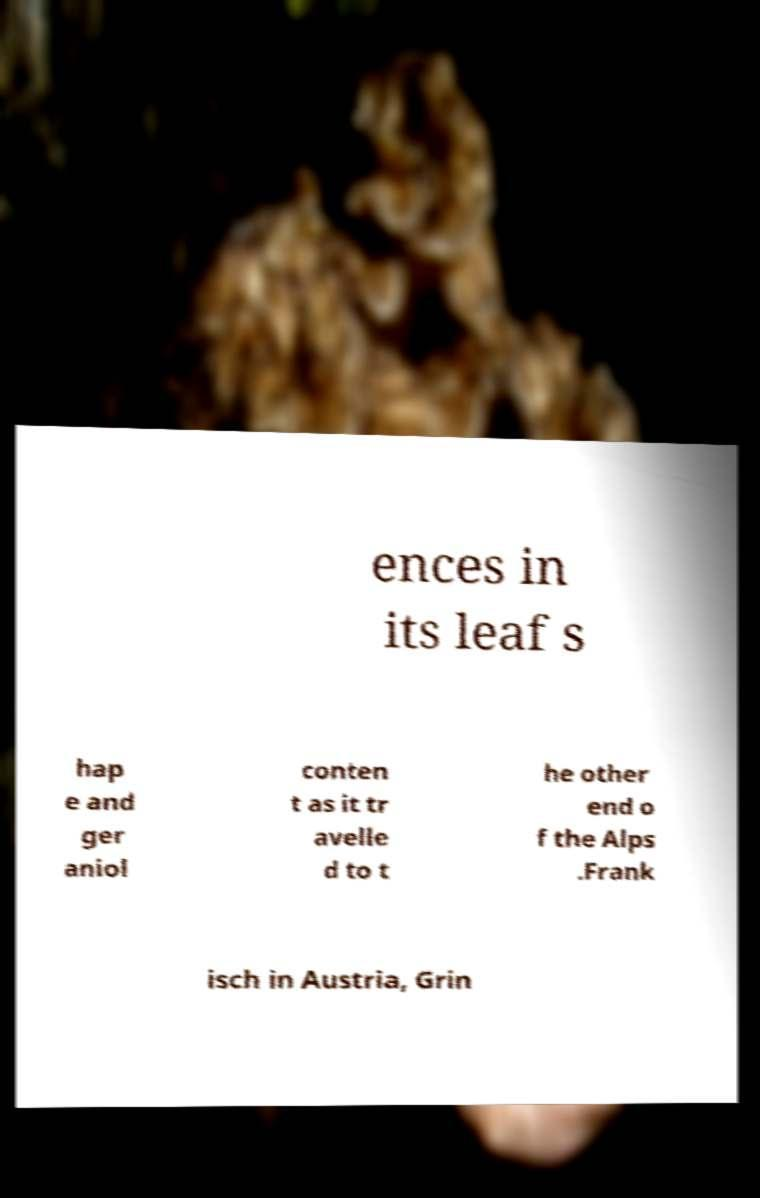Can you read and provide the text displayed in the image?This photo seems to have some interesting text. Can you extract and type it out for me? ences in its leaf s hap e and ger aniol conten t as it tr avelle d to t he other end o f the Alps .Frank isch in Austria, Grin 